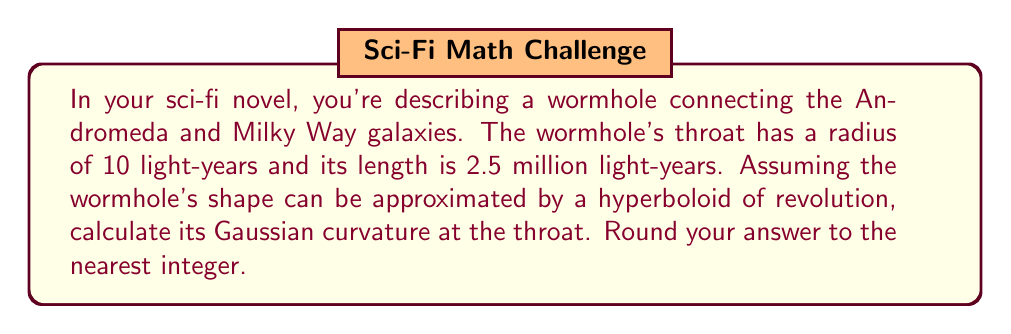Help me with this question. Let's approach this step-by-step:

1) The Gaussian curvature (K) of a hyperboloid of revolution at its throat is given by the formula:

   $$K = -\frac{1}{a^2}$$

   where $a$ is the radius of the throat.

2) We're given that the radius of the throat is 10 light-years, so $a = 10$.

3) Substituting this into our formula:

   $$K = -\frac{1}{10^2} = -\frac{1}{100} = -0.01$$

4) The question asks for the answer rounded to the nearest integer. Since -0.01 is closer to 0 than to -1, we round it to 0.

Note: The length of the wormhole (2.5 million light-years) isn't needed for this calculation, but it helps set the scale for your sci-fi narrative. The negative curvature indicates that the wormhole's throat is a saddle-like surface, which is consistent with our understanding of traversable wormholes in theory.
Answer: 0 